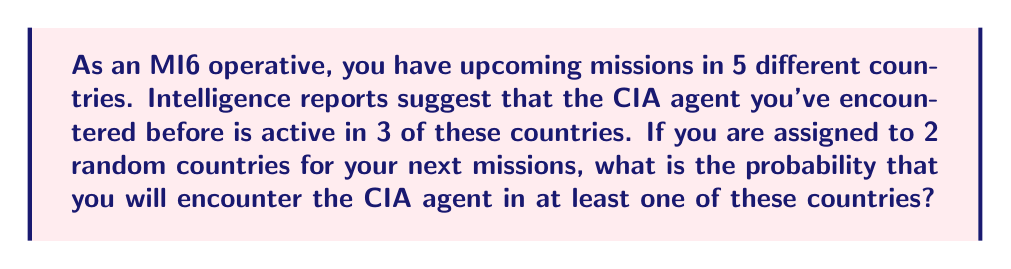Can you answer this question? Let's approach this problem using set theory and probability:

1) First, let's define our sets:
   $U$ = Set of all countries you might be assigned to (5 countries)
   $C$ = Set of countries where the CIA agent is active (3 countries)

2) We need to find the probability of encountering the CIA agent in at least one of the two countries. This is equivalent to 1 minus the probability of not encountering the agent in either country.

3) The probability of selecting a country where the CIA agent is not active for the first mission is:

   $$P(\text{No CIA in 1st}) = \frac{|U| - |C|}{|U|} = \frac{5-3}{5} = \frac{2}{5}$$

4) Given that the first country doesn't have the CIA agent, the probability that the second country also doesn't have the CIA agent is:

   $$P(\text{No CIA in 2nd | No CIA in 1st}) = \frac{1}{4}$$

5) The probability of not encountering the CIA agent in either country is:

   $$P(\text{No CIA in both}) = \frac{2}{5} \cdot \frac{1}{4} = \frac{1}{10}$$

6) Therefore, the probability of encountering the CIA agent in at least one country is:

   $$P(\text{CIA in at least one}) = 1 - P(\text{No CIA in both}) = 1 - \frac{1}{10} = \frac{9}{10}$$
Answer: The probability of encountering the CIA agent in at least one of the two randomly assigned countries is $\frac{9}{10}$ or 90%. 